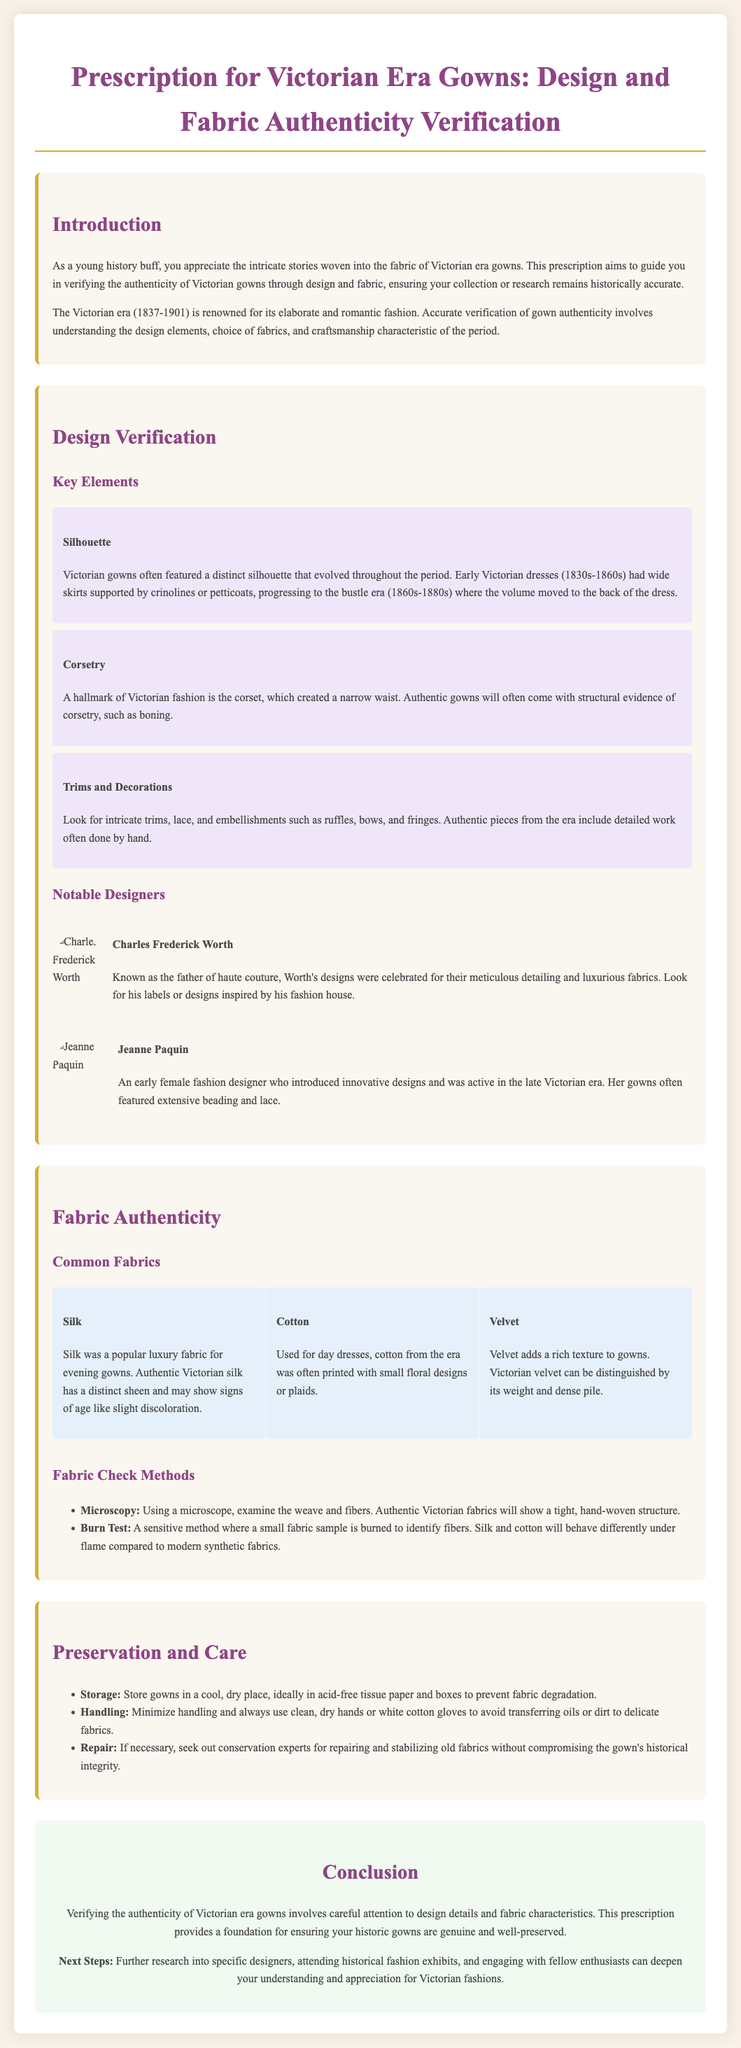what years does the Victorian era cover? The Victorian era is defined by the years during which Queen Victoria reigned. The document states these years as 1837-1901.
Answer: 1837-1901 who is known as the father of haute couture? The document names Charles Frederick Worth as the father of haute couture.
Answer: Charles Frederick Worth what is one distinct feature of the Victorian gown silhouette? The document describes that early Victorian dresses had wide skirts supported by crinolines or petticoats.
Answer: Wide skirts which fabric was typically used for evening gowns? According to the fabric section, silk was a popular luxury fabric for evening gowns during the Victorian era.
Answer: Silk what method can be used to check fabric authenticity? The document lists several methods, with microscopy being one of them for checking the authenticity of fabrics.
Answer: Microscopy who was an early female fashion designer mentioned in the document? The document mentions Jeanne Paquin as an early female fashion designer active in the late Victorian era.
Answer: Jeanne Paquin what should you use when handling delicate fabrics? The document suggests using clean, dry hands or white cotton gloves when handling delicate fabrics to avoid transferring oils or dirt.
Answer: White cotton gloves what type of storage is recommended for gowns? The document recommends storing gowns in a cool, dry place, ideally in acid-free tissue paper and boxes.
Answer: Acid-free tissue paper and boxes how many common fabric types are listed in the document? The document mentions three common fabric types used in Victorian gowns: silk, cotton, and velvet.
Answer: Three 